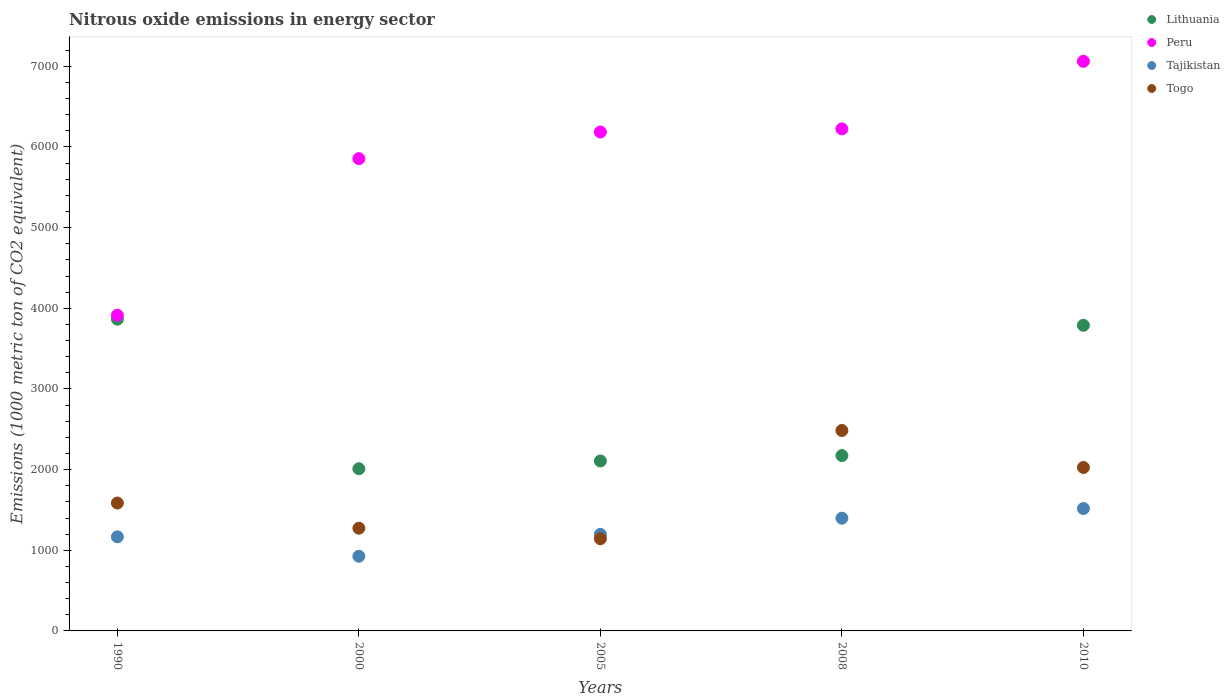Is the number of dotlines equal to the number of legend labels?
Ensure brevity in your answer.  Yes. What is the amount of nitrous oxide emitted in Togo in 2000?
Provide a short and direct response. 1273.3. Across all years, what is the maximum amount of nitrous oxide emitted in Togo?
Keep it short and to the point. 2485.1. Across all years, what is the minimum amount of nitrous oxide emitted in Togo?
Your answer should be very brief. 1142.8. In which year was the amount of nitrous oxide emitted in Tajikistan minimum?
Keep it short and to the point. 2000. What is the total amount of nitrous oxide emitted in Peru in the graph?
Provide a short and direct response. 2.92e+04. What is the difference between the amount of nitrous oxide emitted in Lithuania in 2000 and that in 2008?
Your answer should be compact. -163.1. What is the difference between the amount of nitrous oxide emitted in Togo in 2005 and the amount of nitrous oxide emitted in Tajikistan in 2010?
Your response must be concise. -374.2. What is the average amount of nitrous oxide emitted in Togo per year?
Keep it short and to the point. 1702.7. In the year 2005, what is the difference between the amount of nitrous oxide emitted in Peru and amount of nitrous oxide emitted in Lithuania?
Make the answer very short. 4078.8. In how many years, is the amount of nitrous oxide emitted in Lithuania greater than 2800 1000 metric ton?
Your answer should be compact. 2. What is the ratio of the amount of nitrous oxide emitted in Peru in 1990 to that in 2005?
Make the answer very short. 0.63. Is the amount of nitrous oxide emitted in Tajikistan in 2000 less than that in 2008?
Give a very brief answer. Yes. What is the difference between the highest and the second highest amount of nitrous oxide emitted in Tajikistan?
Your response must be concise. 119.4. What is the difference between the highest and the lowest amount of nitrous oxide emitted in Lithuania?
Provide a short and direct response. 1854.2. Is the sum of the amount of nitrous oxide emitted in Peru in 2000 and 2008 greater than the maximum amount of nitrous oxide emitted in Tajikistan across all years?
Provide a succinct answer. Yes. Does the amount of nitrous oxide emitted in Lithuania monotonically increase over the years?
Your answer should be very brief. No. Is the amount of nitrous oxide emitted in Tajikistan strictly greater than the amount of nitrous oxide emitted in Peru over the years?
Make the answer very short. No. How many dotlines are there?
Offer a terse response. 4. Does the graph contain any zero values?
Keep it short and to the point. No. What is the title of the graph?
Provide a succinct answer. Nitrous oxide emissions in energy sector. Does "Dominican Republic" appear as one of the legend labels in the graph?
Ensure brevity in your answer.  No. What is the label or title of the Y-axis?
Your answer should be very brief. Emissions (1000 metric ton of CO2 equivalent). What is the Emissions (1000 metric ton of CO2 equivalent) of Lithuania in 1990?
Your answer should be very brief. 3865. What is the Emissions (1000 metric ton of CO2 equivalent) in Peru in 1990?
Make the answer very short. 3914.1. What is the Emissions (1000 metric ton of CO2 equivalent) in Tajikistan in 1990?
Your response must be concise. 1166.5. What is the Emissions (1000 metric ton of CO2 equivalent) in Togo in 1990?
Provide a succinct answer. 1585.7. What is the Emissions (1000 metric ton of CO2 equivalent) of Lithuania in 2000?
Your answer should be very brief. 2010.8. What is the Emissions (1000 metric ton of CO2 equivalent) of Peru in 2000?
Keep it short and to the point. 5854.9. What is the Emissions (1000 metric ton of CO2 equivalent) of Tajikistan in 2000?
Your response must be concise. 925.5. What is the Emissions (1000 metric ton of CO2 equivalent) of Togo in 2000?
Provide a short and direct response. 1273.3. What is the Emissions (1000 metric ton of CO2 equivalent) in Lithuania in 2005?
Keep it short and to the point. 2107. What is the Emissions (1000 metric ton of CO2 equivalent) of Peru in 2005?
Offer a very short reply. 6185.8. What is the Emissions (1000 metric ton of CO2 equivalent) of Tajikistan in 2005?
Ensure brevity in your answer.  1197.3. What is the Emissions (1000 metric ton of CO2 equivalent) of Togo in 2005?
Provide a succinct answer. 1142.8. What is the Emissions (1000 metric ton of CO2 equivalent) in Lithuania in 2008?
Your answer should be compact. 2173.9. What is the Emissions (1000 metric ton of CO2 equivalent) of Peru in 2008?
Make the answer very short. 6224.5. What is the Emissions (1000 metric ton of CO2 equivalent) in Tajikistan in 2008?
Your response must be concise. 1397.6. What is the Emissions (1000 metric ton of CO2 equivalent) in Togo in 2008?
Ensure brevity in your answer.  2485.1. What is the Emissions (1000 metric ton of CO2 equivalent) in Lithuania in 2010?
Offer a terse response. 3789.1. What is the Emissions (1000 metric ton of CO2 equivalent) of Peru in 2010?
Ensure brevity in your answer.  7062. What is the Emissions (1000 metric ton of CO2 equivalent) of Tajikistan in 2010?
Ensure brevity in your answer.  1517. What is the Emissions (1000 metric ton of CO2 equivalent) of Togo in 2010?
Your answer should be very brief. 2026.6. Across all years, what is the maximum Emissions (1000 metric ton of CO2 equivalent) in Lithuania?
Your answer should be compact. 3865. Across all years, what is the maximum Emissions (1000 metric ton of CO2 equivalent) of Peru?
Offer a very short reply. 7062. Across all years, what is the maximum Emissions (1000 metric ton of CO2 equivalent) in Tajikistan?
Provide a succinct answer. 1517. Across all years, what is the maximum Emissions (1000 metric ton of CO2 equivalent) of Togo?
Keep it short and to the point. 2485.1. Across all years, what is the minimum Emissions (1000 metric ton of CO2 equivalent) in Lithuania?
Provide a short and direct response. 2010.8. Across all years, what is the minimum Emissions (1000 metric ton of CO2 equivalent) of Peru?
Your answer should be very brief. 3914.1. Across all years, what is the minimum Emissions (1000 metric ton of CO2 equivalent) of Tajikistan?
Provide a short and direct response. 925.5. Across all years, what is the minimum Emissions (1000 metric ton of CO2 equivalent) in Togo?
Provide a succinct answer. 1142.8. What is the total Emissions (1000 metric ton of CO2 equivalent) of Lithuania in the graph?
Offer a very short reply. 1.39e+04. What is the total Emissions (1000 metric ton of CO2 equivalent) in Peru in the graph?
Your response must be concise. 2.92e+04. What is the total Emissions (1000 metric ton of CO2 equivalent) of Tajikistan in the graph?
Your answer should be very brief. 6203.9. What is the total Emissions (1000 metric ton of CO2 equivalent) of Togo in the graph?
Offer a very short reply. 8513.5. What is the difference between the Emissions (1000 metric ton of CO2 equivalent) in Lithuania in 1990 and that in 2000?
Offer a very short reply. 1854.2. What is the difference between the Emissions (1000 metric ton of CO2 equivalent) of Peru in 1990 and that in 2000?
Your response must be concise. -1940.8. What is the difference between the Emissions (1000 metric ton of CO2 equivalent) of Tajikistan in 1990 and that in 2000?
Offer a terse response. 241. What is the difference between the Emissions (1000 metric ton of CO2 equivalent) in Togo in 1990 and that in 2000?
Offer a very short reply. 312.4. What is the difference between the Emissions (1000 metric ton of CO2 equivalent) of Lithuania in 1990 and that in 2005?
Make the answer very short. 1758. What is the difference between the Emissions (1000 metric ton of CO2 equivalent) in Peru in 1990 and that in 2005?
Offer a very short reply. -2271.7. What is the difference between the Emissions (1000 metric ton of CO2 equivalent) in Tajikistan in 1990 and that in 2005?
Your answer should be very brief. -30.8. What is the difference between the Emissions (1000 metric ton of CO2 equivalent) in Togo in 1990 and that in 2005?
Keep it short and to the point. 442.9. What is the difference between the Emissions (1000 metric ton of CO2 equivalent) of Lithuania in 1990 and that in 2008?
Offer a terse response. 1691.1. What is the difference between the Emissions (1000 metric ton of CO2 equivalent) in Peru in 1990 and that in 2008?
Provide a succinct answer. -2310.4. What is the difference between the Emissions (1000 metric ton of CO2 equivalent) of Tajikistan in 1990 and that in 2008?
Your answer should be very brief. -231.1. What is the difference between the Emissions (1000 metric ton of CO2 equivalent) in Togo in 1990 and that in 2008?
Offer a terse response. -899.4. What is the difference between the Emissions (1000 metric ton of CO2 equivalent) in Lithuania in 1990 and that in 2010?
Make the answer very short. 75.9. What is the difference between the Emissions (1000 metric ton of CO2 equivalent) in Peru in 1990 and that in 2010?
Your answer should be compact. -3147.9. What is the difference between the Emissions (1000 metric ton of CO2 equivalent) of Tajikistan in 1990 and that in 2010?
Keep it short and to the point. -350.5. What is the difference between the Emissions (1000 metric ton of CO2 equivalent) in Togo in 1990 and that in 2010?
Give a very brief answer. -440.9. What is the difference between the Emissions (1000 metric ton of CO2 equivalent) of Lithuania in 2000 and that in 2005?
Your response must be concise. -96.2. What is the difference between the Emissions (1000 metric ton of CO2 equivalent) of Peru in 2000 and that in 2005?
Your answer should be compact. -330.9. What is the difference between the Emissions (1000 metric ton of CO2 equivalent) of Tajikistan in 2000 and that in 2005?
Provide a succinct answer. -271.8. What is the difference between the Emissions (1000 metric ton of CO2 equivalent) of Togo in 2000 and that in 2005?
Your answer should be compact. 130.5. What is the difference between the Emissions (1000 metric ton of CO2 equivalent) in Lithuania in 2000 and that in 2008?
Your answer should be compact. -163.1. What is the difference between the Emissions (1000 metric ton of CO2 equivalent) of Peru in 2000 and that in 2008?
Provide a succinct answer. -369.6. What is the difference between the Emissions (1000 metric ton of CO2 equivalent) in Tajikistan in 2000 and that in 2008?
Offer a very short reply. -472.1. What is the difference between the Emissions (1000 metric ton of CO2 equivalent) of Togo in 2000 and that in 2008?
Provide a short and direct response. -1211.8. What is the difference between the Emissions (1000 metric ton of CO2 equivalent) in Lithuania in 2000 and that in 2010?
Offer a very short reply. -1778.3. What is the difference between the Emissions (1000 metric ton of CO2 equivalent) of Peru in 2000 and that in 2010?
Ensure brevity in your answer.  -1207.1. What is the difference between the Emissions (1000 metric ton of CO2 equivalent) in Tajikistan in 2000 and that in 2010?
Offer a terse response. -591.5. What is the difference between the Emissions (1000 metric ton of CO2 equivalent) in Togo in 2000 and that in 2010?
Provide a succinct answer. -753.3. What is the difference between the Emissions (1000 metric ton of CO2 equivalent) of Lithuania in 2005 and that in 2008?
Your response must be concise. -66.9. What is the difference between the Emissions (1000 metric ton of CO2 equivalent) of Peru in 2005 and that in 2008?
Offer a terse response. -38.7. What is the difference between the Emissions (1000 metric ton of CO2 equivalent) of Tajikistan in 2005 and that in 2008?
Offer a terse response. -200.3. What is the difference between the Emissions (1000 metric ton of CO2 equivalent) in Togo in 2005 and that in 2008?
Your response must be concise. -1342.3. What is the difference between the Emissions (1000 metric ton of CO2 equivalent) of Lithuania in 2005 and that in 2010?
Ensure brevity in your answer.  -1682.1. What is the difference between the Emissions (1000 metric ton of CO2 equivalent) of Peru in 2005 and that in 2010?
Your answer should be compact. -876.2. What is the difference between the Emissions (1000 metric ton of CO2 equivalent) of Tajikistan in 2005 and that in 2010?
Give a very brief answer. -319.7. What is the difference between the Emissions (1000 metric ton of CO2 equivalent) in Togo in 2005 and that in 2010?
Provide a succinct answer. -883.8. What is the difference between the Emissions (1000 metric ton of CO2 equivalent) of Lithuania in 2008 and that in 2010?
Ensure brevity in your answer.  -1615.2. What is the difference between the Emissions (1000 metric ton of CO2 equivalent) of Peru in 2008 and that in 2010?
Keep it short and to the point. -837.5. What is the difference between the Emissions (1000 metric ton of CO2 equivalent) of Tajikistan in 2008 and that in 2010?
Provide a succinct answer. -119.4. What is the difference between the Emissions (1000 metric ton of CO2 equivalent) in Togo in 2008 and that in 2010?
Keep it short and to the point. 458.5. What is the difference between the Emissions (1000 metric ton of CO2 equivalent) in Lithuania in 1990 and the Emissions (1000 metric ton of CO2 equivalent) in Peru in 2000?
Make the answer very short. -1989.9. What is the difference between the Emissions (1000 metric ton of CO2 equivalent) of Lithuania in 1990 and the Emissions (1000 metric ton of CO2 equivalent) of Tajikistan in 2000?
Give a very brief answer. 2939.5. What is the difference between the Emissions (1000 metric ton of CO2 equivalent) in Lithuania in 1990 and the Emissions (1000 metric ton of CO2 equivalent) in Togo in 2000?
Provide a short and direct response. 2591.7. What is the difference between the Emissions (1000 metric ton of CO2 equivalent) in Peru in 1990 and the Emissions (1000 metric ton of CO2 equivalent) in Tajikistan in 2000?
Your answer should be compact. 2988.6. What is the difference between the Emissions (1000 metric ton of CO2 equivalent) in Peru in 1990 and the Emissions (1000 metric ton of CO2 equivalent) in Togo in 2000?
Your answer should be very brief. 2640.8. What is the difference between the Emissions (1000 metric ton of CO2 equivalent) in Tajikistan in 1990 and the Emissions (1000 metric ton of CO2 equivalent) in Togo in 2000?
Make the answer very short. -106.8. What is the difference between the Emissions (1000 metric ton of CO2 equivalent) of Lithuania in 1990 and the Emissions (1000 metric ton of CO2 equivalent) of Peru in 2005?
Give a very brief answer. -2320.8. What is the difference between the Emissions (1000 metric ton of CO2 equivalent) in Lithuania in 1990 and the Emissions (1000 metric ton of CO2 equivalent) in Tajikistan in 2005?
Provide a succinct answer. 2667.7. What is the difference between the Emissions (1000 metric ton of CO2 equivalent) of Lithuania in 1990 and the Emissions (1000 metric ton of CO2 equivalent) of Togo in 2005?
Offer a very short reply. 2722.2. What is the difference between the Emissions (1000 metric ton of CO2 equivalent) of Peru in 1990 and the Emissions (1000 metric ton of CO2 equivalent) of Tajikistan in 2005?
Make the answer very short. 2716.8. What is the difference between the Emissions (1000 metric ton of CO2 equivalent) in Peru in 1990 and the Emissions (1000 metric ton of CO2 equivalent) in Togo in 2005?
Ensure brevity in your answer.  2771.3. What is the difference between the Emissions (1000 metric ton of CO2 equivalent) in Tajikistan in 1990 and the Emissions (1000 metric ton of CO2 equivalent) in Togo in 2005?
Give a very brief answer. 23.7. What is the difference between the Emissions (1000 metric ton of CO2 equivalent) of Lithuania in 1990 and the Emissions (1000 metric ton of CO2 equivalent) of Peru in 2008?
Provide a short and direct response. -2359.5. What is the difference between the Emissions (1000 metric ton of CO2 equivalent) of Lithuania in 1990 and the Emissions (1000 metric ton of CO2 equivalent) of Tajikistan in 2008?
Offer a very short reply. 2467.4. What is the difference between the Emissions (1000 metric ton of CO2 equivalent) in Lithuania in 1990 and the Emissions (1000 metric ton of CO2 equivalent) in Togo in 2008?
Offer a terse response. 1379.9. What is the difference between the Emissions (1000 metric ton of CO2 equivalent) in Peru in 1990 and the Emissions (1000 metric ton of CO2 equivalent) in Tajikistan in 2008?
Offer a very short reply. 2516.5. What is the difference between the Emissions (1000 metric ton of CO2 equivalent) in Peru in 1990 and the Emissions (1000 metric ton of CO2 equivalent) in Togo in 2008?
Your answer should be compact. 1429. What is the difference between the Emissions (1000 metric ton of CO2 equivalent) of Tajikistan in 1990 and the Emissions (1000 metric ton of CO2 equivalent) of Togo in 2008?
Offer a very short reply. -1318.6. What is the difference between the Emissions (1000 metric ton of CO2 equivalent) of Lithuania in 1990 and the Emissions (1000 metric ton of CO2 equivalent) of Peru in 2010?
Give a very brief answer. -3197. What is the difference between the Emissions (1000 metric ton of CO2 equivalent) in Lithuania in 1990 and the Emissions (1000 metric ton of CO2 equivalent) in Tajikistan in 2010?
Provide a succinct answer. 2348. What is the difference between the Emissions (1000 metric ton of CO2 equivalent) in Lithuania in 1990 and the Emissions (1000 metric ton of CO2 equivalent) in Togo in 2010?
Provide a short and direct response. 1838.4. What is the difference between the Emissions (1000 metric ton of CO2 equivalent) of Peru in 1990 and the Emissions (1000 metric ton of CO2 equivalent) of Tajikistan in 2010?
Give a very brief answer. 2397.1. What is the difference between the Emissions (1000 metric ton of CO2 equivalent) in Peru in 1990 and the Emissions (1000 metric ton of CO2 equivalent) in Togo in 2010?
Keep it short and to the point. 1887.5. What is the difference between the Emissions (1000 metric ton of CO2 equivalent) in Tajikistan in 1990 and the Emissions (1000 metric ton of CO2 equivalent) in Togo in 2010?
Provide a succinct answer. -860.1. What is the difference between the Emissions (1000 metric ton of CO2 equivalent) in Lithuania in 2000 and the Emissions (1000 metric ton of CO2 equivalent) in Peru in 2005?
Your answer should be very brief. -4175. What is the difference between the Emissions (1000 metric ton of CO2 equivalent) in Lithuania in 2000 and the Emissions (1000 metric ton of CO2 equivalent) in Tajikistan in 2005?
Your response must be concise. 813.5. What is the difference between the Emissions (1000 metric ton of CO2 equivalent) of Lithuania in 2000 and the Emissions (1000 metric ton of CO2 equivalent) of Togo in 2005?
Give a very brief answer. 868. What is the difference between the Emissions (1000 metric ton of CO2 equivalent) in Peru in 2000 and the Emissions (1000 metric ton of CO2 equivalent) in Tajikistan in 2005?
Give a very brief answer. 4657.6. What is the difference between the Emissions (1000 metric ton of CO2 equivalent) of Peru in 2000 and the Emissions (1000 metric ton of CO2 equivalent) of Togo in 2005?
Your answer should be compact. 4712.1. What is the difference between the Emissions (1000 metric ton of CO2 equivalent) in Tajikistan in 2000 and the Emissions (1000 metric ton of CO2 equivalent) in Togo in 2005?
Your answer should be compact. -217.3. What is the difference between the Emissions (1000 metric ton of CO2 equivalent) of Lithuania in 2000 and the Emissions (1000 metric ton of CO2 equivalent) of Peru in 2008?
Make the answer very short. -4213.7. What is the difference between the Emissions (1000 metric ton of CO2 equivalent) in Lithuania in 2000 and the Emissions (1000 metric ton of CO2 equivalent) in Tajikistan in 2008?
Offer a terse response. 613.2. What is the difference between the Emissions (1000 metric ton of CO2 equivalent) in Lithuania in 2000 and the Emissions (1000 metric ton of CO2 equivalent) in Togo in 2008?
Provide a short and direct response. -474.3. What is the difference between the Emissions (1000 metric ton of CO2 equivalent) of Peru in 2000 and the Emissions (1000 metric ton of CO2 equivalent) of Tajikistan in 2008?
Your response must be concise. 4457.3. What is the difference between the Emissions (1000 metric ton of CO2 equivalent) in Peru in 2000 and the Emissions (1000 metric ton of CO2 equivalent) in Togo in 2008?
Provide a short and direct response. 3369.8. What is the difference between the Emissions (1000 metric ton of CO2 equivalent) in Tajikistan in 2000 and the Emissions (1000 metric ton of CO2 equivalent) in Togo in 2008?
Your answer should be very brief. -1559.6. What is the difference between the Emissions (1000 metric ton of CO2 equivalent) of Lithuania in 2000 and the Emissions (1000 metric ton of CO2 equivalent) of Peru in 2010?
Offer a terse response. -5051.2. What is the difference between the Emissions (1000 metric ton of CO2 equivalent) in Lithuania in 2000 and the Emissions (1000 metric ton of CO2 equivalent) in Tajikistan in 2010?
Offer a very short reply. 493.8. What is the difference between the Emissions (1000 metric ton of CO2 equivalent) in Lithuania in 2000 and the Emissions (1000 metric ton of CO2 equivalent) in Togo in 2010?
Give a very brief answer. -15.8. What is the difference between the Emissions (1000 metric ton of CO2 equivalent) in Peru in 2000 and the Emissions (1000 metric ton of CO2 equivalent) in Tajikistan in 2010?
Offer a terse response. 4337.9. What is the difference between the Emissions (1000 metric ton of CO2 equivalent) in Peru in 2000 and the Emissions (1000 metric ton of CO2 equivalent) in Togo in 2010?
Keep it short and to the point. 3828.3. What is the difference between the Emissions (1000 metric ton of CO2 equivalent) of Tajikistan in 2000 and the Emissions (1000 metric ton of CO2 equivalent) of Togo in 2010?
Ensure brevity in your answer.  -1101.1. What is the difference between the Emissions (1000 metric ton of CO2 equivalent) of Lithuania in 2005 and the Emissions (1000 metric ton of CO2 equivalent) of Peru in 2008?
Your answer should be very brief. -4117.5. What is the difference between the Emissions (1000 metric ton of CO2 equivalent) of Lithuania in 2005 and the Emissions (1000 metric ton of CO2 equivalent) of Tajikistan in 2008?
Offer a terse response. 709.4. What is the difference between the Emissions (1000 metric ton of CO2 equivalent) of Lithuania in 2005 and the Emissions (1000 metric ton of CO2 equivalent) of Togo in 2008?
Your answer should be very brief. -378.1. What is the difference between the Emissions (1000 metric ton of CO2 equivalent) in Peru in 2005 and the Emissions (1000 metric ton of CO2 equivalent) in Tajikistan in 2008?
Offer a very short reply. 4788.2. What is the difference between the Emissions (1000 metric ton of CO2 equivalent) of Peru in 2005 and the Emissions (1000 metric ton of CO2 equivalent) of Togo in 2008?
Keep it short and to the point. 3700.7. What is the difference between the Emissions (1000 metric ton of CO2 equivalent) of Tajikistan in 2005 and the Emissions (1000 metric ton of CO2 equivalent) of Togo in 2008?
Give a very brief answer. -1287.8. What is the difference between the Emissions (1000 metric ton of CO2 equivalent) of Lithuania in 2005 and the Emissions (1000 metric ton of CO2 equivalent) of Peru in 2010?
Your response must be concise. -4955. What is the difference between the Emissions (1000 metric ton of CO2 equivalent) in Lithuania in 2005 and the Emissions (1000 metric ton of CO2 equivalent) in Tajikistan in 2010?
Give a very brief answer. 590. What is the difference between the Emissions (1000 metric ton of CO2 equivalent) of Lithuania in 2005 and the Emissions (1000 metric ton of CO2 equivalent) of Togo in 2010?
Your answer should be very brief. 80.4. What is the difference between the Emissions (1000 metric ton of CO2 equivalent) in Peru in 2005 and the Emissions (1000 metric ton of CO2 equivalent) in Tajikistan in 2010?
Provide a short and direct response. 4668.8. What is the difference between the Emissions (1000 metric ton of CO2 equivalent) in Peru in 2005 and the Emissions (1000 metric ton of CO2 equivalent) in Togo in 2010?
Ensure brevity in your answer.  4159.2. What is the difference between the Emissions (1000 metric ton of CO2 equivalent) in Tajikistan in 2005 and the Emissions (1000 metric ton of CO2 equivalent) in Togo in 2010?
Provide a succinct answer. -829.3. What is the difference between the Emissions (1000 metric ton of CO2 equivalent) of Lithuania in 2008 and the Emissions (1000 metric ton of CO2 equivalent) of Peru in 2010?
Keep it short and to the point. -4888.1. What is the difference between the Emissions (1000 metric ton of CO2 equivalent) of Lithuania in 2008 and the Emissions (1000 metric ton of CO2 equivalent) of Tajikistan in 2010?
Ensure brevity in your answer.  656.9. What is the difference between the Emissions (1000 metric ton of CO2 equivalent) in Lithuania in 2008 and the Emissions (1000 metric ton of CO2 equivalent) in Togo in 2010?
Keep it short and to the point. 147.3. What is the difference between the Emissions (1000 metric ton of CO2 equivalent) of Peru in 2008 and the Emissions (1000 metric ton of CO2 equivalent) of Tajikistan in 2010?
Make the answer very short. 4707.5. What is the difference between the Emissions (1000 metric ton of CO2 equivalent) of Peru in 2008 and the Emissions (1000 metric ton of CO2 equivalent) of Togo in 2010?
Give a very brief answer. 4197.9. What is the difference between the Emissions (1000 metric ton of CO2 equivalent) of Tajikistan in 2008 and the Emissions (1000 metric ton of CO2 equivalent) of Togo in 2010?
Make the answer very short. -629. What is the average Emissions (1000 metric ton of CO2 equivalent) in Lithuania per year?
Provide a short and direct response. 2789.16. What is the average Emissions (1000 metric ton of CO2 equivalent) in Peru per year?
Make the answer very short. 5848.26. What is the average Emissions (1000 metric ton of CO2 equivalent) of Tajikistan per year?
Your answer should be compact. 1240.78. What is the average Emissions (1000 metric ton of CO2 equivalent) of Togo per year?
Make the answer very short. 1702.7. In the year 1990, what is the difference between the Emissions (1000 metric ton of CO2 equivalent) in Lithuania and Emissions (1000 metric ton of CO2 equivalent) in Peru?
Offer a terse response. -49.1. In the year 1990, what is the difference between the Emissions (1000 metric ton of CO2 equivalent) of Lithuania and Emissions (1000 metric ton of CO2 equivalent) of Tajikistan?
Offer a very short reply. 2698.5. In the year 1990, what is the difference between the Emissions (1000 metric ton of CO2 equivalent) in Lithuania and Emissions (1000 metric ton of CO2 equivalent) in Togo?
Make the answer very short. 2279.3. In the year 1990, what is the difference between the Emissions (1000 metric ton of CO2 equivalent) of Peru and Emissions (1000 metric ton of CO2 equivalent) of Tajikistan?
Give a very brief answer. 2747.6. In the year 1990, what is the difference between the Emissions (1000 metric ton of CO2 equivalent) in Peru and Emissions (1000 metric ton of CO2 equivalent) in Togo?
Provide a short and direct response. 2328.4. In the year 1990, what is the difference between the Emissions (1000 metric ton of CO2 equivalent) in Tajikistan and Emissions (1000 metric ton of CO2 equivalent) in Togo?
Offer a very short reply. -419.2. In the year 2000, what is the difference between the Emissions (1000 metric ton of CO2 equivalent) of Lithuania and Emissions (1000 metric ton of CO2 equivalent) of Peru?
Offer a terse response. -3844.1. In the year 2000, what is the difference between the Emissions (1000 metric ton of CO2 equivalent) in Lithuania and Emissions (1000 metric ton of CO2 equivalent) in Tajikistan?
Give a very brief answer. 1085.3. In the year 2000, what is the difference between the Emissions (1000 metric ton of CO2 equivalent) of Lithuania and Emissions (1000 metric ton of CO2 equivalent) of Togo?
Make the answer very short. 737.5. In the year 2000, what is the difference between the Emissions (1000 metric ton of CO2 equivalent) of Peru and Emissions (1000 metric ton of CO2 equivalent) of Tajikistan?
Ensure brevity in your answer.  4929.4. In the year 2000, what is the difference between the Emissions (1000 metric ton of CO2 equivalent) of Peru and Emissions (1000 metric ton of CO2 equivalent) of Togo?
Provide a succinct answer. 4581.6. In the year 2000, what is the difference between the Emissions (1000 metric ton of CO2 equivalent) of Tajikistan and Emissions (1000 metric ton of CO2 equivalent) of Togo?
Provide a succinct answer. -347.8. In the year 2005, what is the difference between the Emissions (1000 metric ton of CO2 equivalent) of Lithuania and Emissions (1000 metric ton of CO2 equivalent) of Peru?
Your response must be concise. -4078.8. In the year 2005, what is the difference between the Emissions (1000 metric ton of CO2 equivalent) in Lithuania and Emissions (1000 metric ton of CO2 equivalent) in Tajikistan?
Your answer should be compact. 909.7. In the year 2005, what is the difference between the Emissions (1000 metric ton of CO2 equivalent) in Lithuania and Emissions (1000 metric ton of CO2 equivalent) in Togo?
Provide a succinct answer. 964.2. In the year 2005, what is the difference between the Emissions (1000 metric ton of CO2 equivalent) in Peru and Emissions (1000 metric ton of CO2 equivalent) in Tajikistan?
Make the answer very short. 4988.5. In the year 2005, what is the difference between the Emissions (1000 metric ton of CO2 equivalent) in Peru and Emissions (1000 metric ton of CO2 equivalent) in Togo?
Ensure brevity in your answer.  5043. In the year 2005, what is the difference between the Emissions (1000 metric ton of CO2 equivalent) of Tajikistan and Emissions (1000 metric ton of CO2 equivalent) of Togo?
Provide a succinct answer. 54.5. In the year 2008, what is the difference between the Emissions (1000 metric ton of CO2 equivalent) of Lithuania and Emissions (1000 metric ton of CO2 equivalent) of Peru?
Your answer should be compact. -4050.6. In the year 2008, what is the difference between the Emissions (1000 metric ton of CO2 equivalent) in Lithuania and Emissions (1000 metric ton of CO2 equivalent) in Tajikistan?
Ensure brevity in your answer.  776.3. In the year 2008, what is the difference between the Emissions (1000 metric ton of CO2 equivalent) of Lithuania and Emissions (1000 metric ton of CO2 equivalent) of Togo?
Ensure brevity in your answer.  -311.2. In the year 2008, what is the difference between the Emissions (1000 metric ton of CO2 equivalent) in Peru and Emissions (1000 metric ton of CO2 equivalent) in Tajikistan?
Your answer should be very brief. 4826.9. In the year 2008, what is the difference between the Emissions (1000 metric ton of CO2 equivalent) of Peru and Emissions (1000 metric ton of CO2 equivalent) of Togo?
Offer a terse response. 3739.4. In the year 2008, what is the difference between the Emissions (1000 metric ton of CO2 equivalent) of Tajikistan and Emissions (1000 metric ton of CO2 equivalent) of Togo?
Offer a very short reply. -1087.5. In the year 2010, what is the difference between the Emissions (1000 metric ton of CO2 equivalent) in Lithuania and Emissions (1000 metric ton of CO2 equivalent) in Peru?
Give a very brief answer. -3272.9. In the year 2010, what is the difference between the Emissions (1000 metric ton of CO2 equivalent) in Lithuania and Emissions (1000 metric ton of CO2 equivalent) in Tajikistan?
Keep it short and to the point. 2272.1. In the year 2010, what is the difference between the Emissions (1000 metric ton of CO2 equivalent) of Lithuania and Emissions (1000 metric ton of CO2 equivalent) of Togo?
Keep it short and to the point. 1762.5. In the year 2010, what is the difference between the Emissions (1000 metric ton of CO2 equivalent) in Peru and Emissions (1000 metric ton of CO2 equivalent) in Tajikistan?
Keep it short and to the point. 5545. In the year 2010, what is the difference between the Emissions (1000 metric ton of CO2 equivalent) of Peru and Emissions (1000 metric ton of CO2 equivalent) of Togo?
Make the answer very short. 5035.4. In the year 2010, what is the difference between the Emissions (1000 metric ton of CO2 equivalent) of Tajikistan and Emissions (1000 metric ton of CO2 equivalent) of Togo?
Give a very brief answer. -509.6. What is the ratio of the Emissions (1000 metric ton of CO2 equivalent) of Lithuania in 1990 to that in 2000?
Keep it short and to the point. 1.92. What is the ratio of the Emissions (1000 metric ton of CO2 equivalent) of Peru in 1990 to that in 2000?
Ensure brevity in your answer.  0.67. What is the ratio of the Emissions (1000 metric ton of CO2 equivalent) of Tajikistan in 1990 to that in 2000?
Your response must be concise. 1.26. What is the ratio of the Emissions (1000 metric ton of CO2 equivalent) in Togo in 1990 to that in 2000?
Ensure brevity in your answer.  1.25. What is the ratio of the Emissions (1000 metric ton of CO2 equivalent) in Lithuania in 1990 to that in 2005?
Provide a succinct answer. 1.83. What is the ratio of the Emissions (1000 metric ton of CO2 equivalent) of Peru in 1990 to that in 2005?
Offer a terse response. 0.63. What is the ratio of the Emissions (1000 metric ton of CO2 equivalent) of Tajikistan in 1990 to that in 2005?
Give a very brief answer. 0.97. What is the ratio of the Emissions (1000 metric ton of CO2 equivalent) in Togo in 1990 to that in 2005?
Offer a very short reply. 1.39. What is the ratio of the Emissions (1000 metric ton of CO2 equivalent) in Lithuania in 1990 to that in 2008?
Ensure brevity in your answer.  1.78. What is the ratio of the Emissions (1000 metric ton of CO2 equivalent) of Peru in 1990 to that in 2008?
Your response must be concise. 0.63. What is the ratio of the Emissions (1000 metric ton of CO2 equivalent) in Tajikistan in 1990 to that in 2008?
Your answer should be compact. 0.83. What is the ratio of the Emissions (1000 metric ton of CO2 equivalent) in Togo in 1990 to that in 2008?
Your response must be concise. 0.64. What is the ratio of the Emissions (1000 metric ton of CO2 equivalent) in Lithuania in 1990 to that in 2010?
Your answer should be very brief. 1.02. What is the ratio of the Emissions (1000 metric ton of CO2 equivalent) in Peru in 1990 to that in 2010?
Ensure brevity in your answer.  0.55. What is the ratio of the Emissions (1000 metric ton of CO2 equivalent) in Tajikistan in 1990 to that in 2010?
Offer a terse response. 0.77. What is the ratio of the Emissions (1000 metric ton of CO2 equivalent) of Togo in 1990 to that in 2010?
Offer a terse response. 0.78. What is the ratio of the Emissions (1000 metric ton of CO2 equivalent) of Lithuania in 2000 to that in 2005?
Ensure brevity in your answer.  0.95. What is the ratio of the Emissions (1000 metric ton of CO2 equivalent) in Peru in 2000 to that in 2005?
Give a very brief answer. 0.95. What is the ratio of the Emissions (1000 metric ton of CO2 equivalent) of Tajikistan in 2000 to that in 2005?
Ensure brevity in your answer.  0.77. What is the ratio of the Emissions (1000 metric ton of CO2 equivalent) of Togo in 2000 to that in 2005?
Offer a terse response. 1.11. What is the ratio of the Emissions (1000 metric ton of CO2 equivalent) of Lithuania in 2000 to that in 2008?
Your response must be concise. 0.93. What is the ratio of the Emissions (1000 metric ton of CO2 equivalent) in Peru in 2000 to that in 2008?
Your answer should be very brief. 0.94. What is the ratio of the Emissions (1000 metric ton of CO2 equivalent) in Tajikistan in 2000 to that in 2008?
Provide a succinct answer. 0.66. What is the ratio of the Emissions (1000 metric ton of CO2 equivalent) of Togo in 2000 to that in 2008?
Provide a short and direct response. 0.51. What is the ratio of the Emissions (1000 metric ton of CO2 equivalent) in Lithuania in 2000 to that in 2010?
Provide a short and direct response. 0.53. What is the ratio of the Emissions (1000 metric ton of CO2 equivalent) in Peru in 2000 to that in 2010?
Your answer should be very brief. 0.83. What is the ratio of the Emissions (1000 metric ton of CO2 equivalent) in Tajikistan in 2000 to that in 2010?
Ensure brevity in your answer.  0.61. What is the ratio of the Emissions (1000 metric ton of CO2 equivalent) in Togo in 2000 to that in 2010?
Ensure brevity in your answer.  0.63. What is the ratio of the Emissions (1000 metric ton of CO2 equivalent) of Lithuania in 2005 to that in 2008?
Provide a short and direct response. 0.97. What is the ratio of the Emissions (1000 metric ton of CO2 equivalent) in Peru in 2005 to that in 2008?
Provide a succinct answer. 0.99. What is the ratio of the Emissions (1000 metric ton of CO2 equivalent) in Tajikistan in 2005 to that in 2008?
Provide a short and direct response. 0.86. What is the ratio of the Emissions (1000 metric ton of CO2 equivalent) in Togo in 2005 to that in 2008?
Keep it short and to the point. 0.46. What is the ratio of the Emissions (1000 metric ton of CO2 equivalent) of Lithuania in 2005 to that in 2010?
Your answer should be compact. 0.56. What is the ratio of the Emissions (1000 metric ton of CO2 equivalent) of Peru in 2005 to that in 2010?
Your answer should be very brief. 0.88. What is the ratio of the Emissions (1000 metric ton of CO2 equivalent) in Tajikistan in 2005 to that in 2010?
Give a very brief answer. 0.79. What is the ratio of the Emissions (1000 metric ton of CO2 equivalent) in Togo in 2005 to that in 2010?
Your answer should be very brief. 0.56. What is the ratio of the Emissions (1000 metric ton of CO2 equivalent) of Lithuania in 2008 to that in 2010?
Provide a succinct answer. 0.57. What is the ratio of the Emissions (1000 metric ton of CO2 equivalent) in Peru in 2008 to that in 2010?
Your answer should be very brief. 0.88. What is the ratio of the Emissions (1000 metric ton of CO2 equivalent) of Tajikistan in 2008 to that in 2010?
Offer a very short reply. 0.92. What is the ratio of the Emissions (1000 metric ton of CO2 equivalent) in Togo in 2008 to that in 2010?
Make the answer very short. 1.23. What is the difference between the highest and the second highest Emissions (1000 metric ton of CO2 equivalent) of Lithuania?
Ensure brevity in your answer.  75.9. What is the difference between the highest and the second highest Emissions (1000 metric ton of CO2 equivalent) in Peru?
Ensure brevity in your answer.  837.5. What is the difference between the highest and the second highest Emissions (1000 metric ton of CO2 equivalent) in Tajikistan?
Provide a short and direct response. 119.4. What is the difference between the highest and the second highest Emissions (1000 metric ton of CO2 equivalent) of Togo?
Keep it short and to the point. 458.5. What is the difference between the highest and the lowest Emissions (1000 metric ton of CO2 equivalent) in Lithuania?
Give a very brief answer. 1854.2. What is the difference between the highest and the lowest Emissions (1000 metric ton of CO2 equivalent) in Peru?
Offer a terse response. 3147.9. What is the difference between the highest and the lowest Emissions (1000 metric ton of CO2 equivalent) of Tajikistan?
Your answer should be compact. 591.5. What is the difference between the highest and the lowest Emissions (1000 metric ton of CO2 equivalent) in Togo?
Your answer should be compact. 1342.3. 